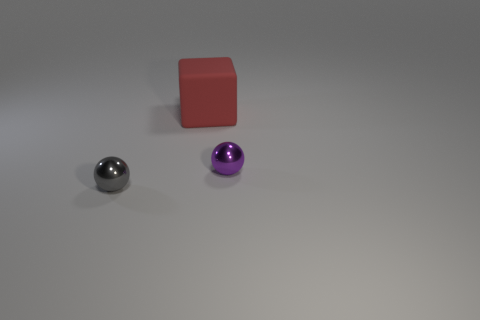Add 1 small gray spheres. How many objects exist? 4 Subtract 2 balls. How many balls are left? 0 Subtract all blocks. How many objects are left? 2 Add 3 gray matte cubes. How many gray matte cubes exist? 3 Subtract 0 green spheres. How many objects are left? 3 Subtract all cyan balls. Subtract all gray blocks. How many balls are left? 2 Subtract all purple cylinders. How many gray blocks are left? 0 Subtract all shiny objects. Subtract all small green metallic balls. How many objects are left? 1 Add 1 large red matte blocks. How many large red matte blocks are left? 2 